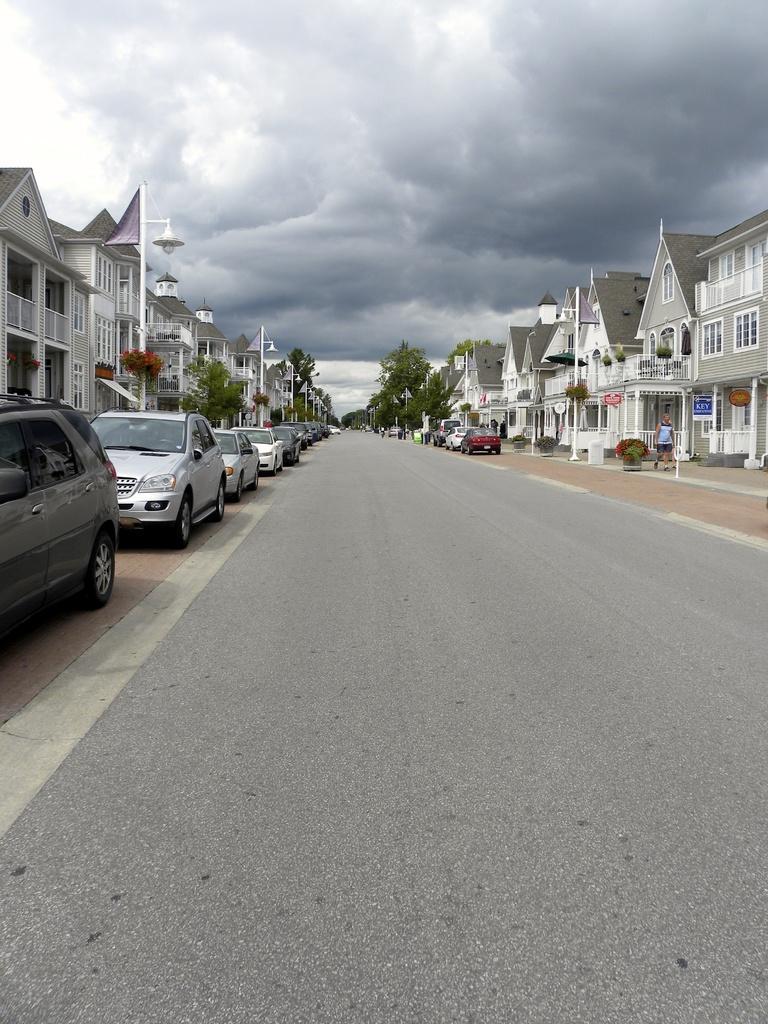How would you summarize this image in a sentence or two? These are the cars, which are parked. I can see the houses with the windows. Here is a person standing. These are the trees and small plants. I think these are the street lights. I can see the clouds in the sky. This is the road. 